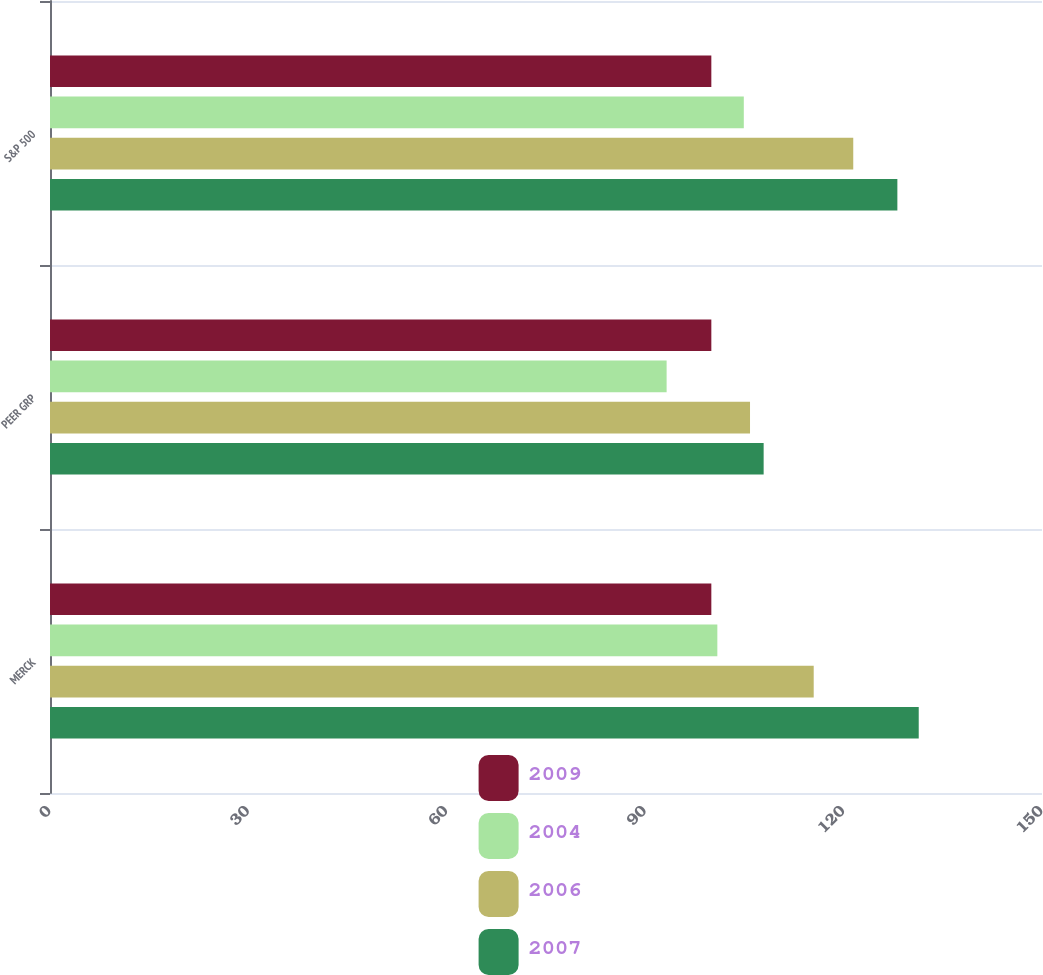Convert chart. <chart><loc_0><loc_0><loc_500><loc_500><stacked_bar_chart><ecel><fcel>MERCK<fcel>PEER GRP<fcel>S&P 500<nl><fcel>2009<fcel>100<fcel>100<fcel>100<nl><fcel>2004<fcel>100.91<fcel>93.24<fcel>104.91<nl><fcel>2006<fcel>115.48<fcel>105.85<fcel>121.46<nl><fcel>2007<fcel>131.36<fcel>107.91<fcel>128.13<nl></chart> 